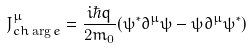Convert formula to latex. <formula><loc_0><loc_0><loc_500><loc_500>J _ { c h \arg e } ^ { \mu } = { \frac { i \hbar { q } } { 2 m _ { 0 } } } ( \psi ^ { * } \partial ^ { \mu } \psi - \psi \partial ^ { \mu } \psi ^ { * } )</formula> 